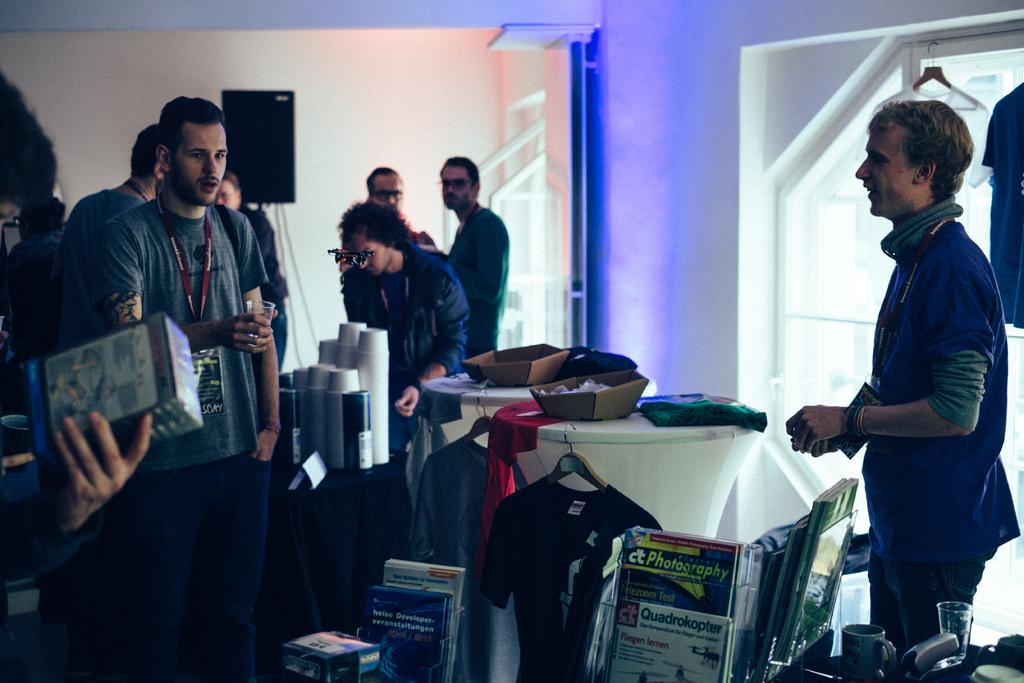What is the position of the man on the right side of the image? The man is standing on the right side of the image. What is the man on the right side wearing? The man is wearing a blue color t-shirt. What is the man on the right side doing? The man is talking. What can be seen in the middle of the image? There are tables in the middle of the image. What is the man on the left side of the image doing? The man on the left side is looking at the other elements in the image. What type of crate is being attacked by the hot air balloon in the image? There is no hot air balloon or crate present in the image. 